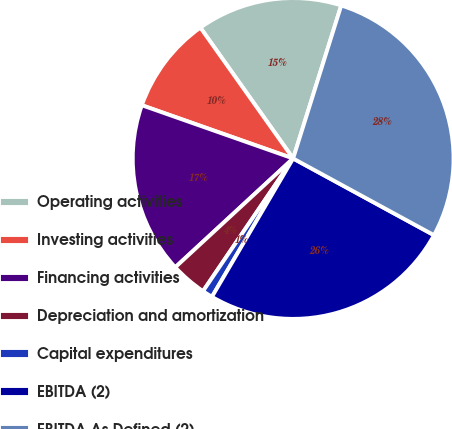Convert chart to OTSL. <chart><loc_0><loc_0><loc_500><loc_500><pie_chart><fcel>Operating activities<fcel>Investing activities<fcel>Financing activities<fcel>Depreciation and amortization<fcel>Capital expenditures<fcel>EBITDA (2)<fcel>EBITDA As Defined (2)<nl><fcel>14.66%<fcel>9.8%<fcel>17.25%<fcel>3.64%<fcel>1.05%<fcel>25.51%<fcel>28.09%<nl></chart> 